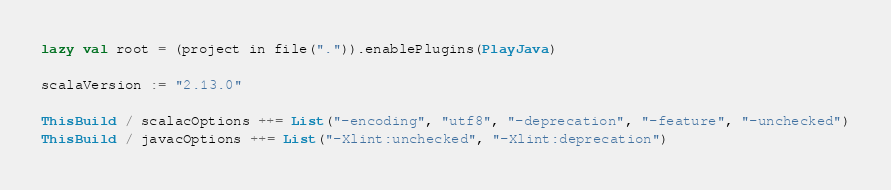Convert code to text. <code><loc_0><loc_0><loc_500><loc_500><_Scala_>
lazy val root = (project in file(".")).enablePlugins(PlayJava)

scalaVersion := "2.13.0"

ThisBuild / scalacOptions ++= List("-encoding", "utf8", "-deprecation", "-feature", "-unchecked")
ThisBuild / javacOptions ++= List("-Xlint:unchecked", "-Xlint:deprecation")
</code> 